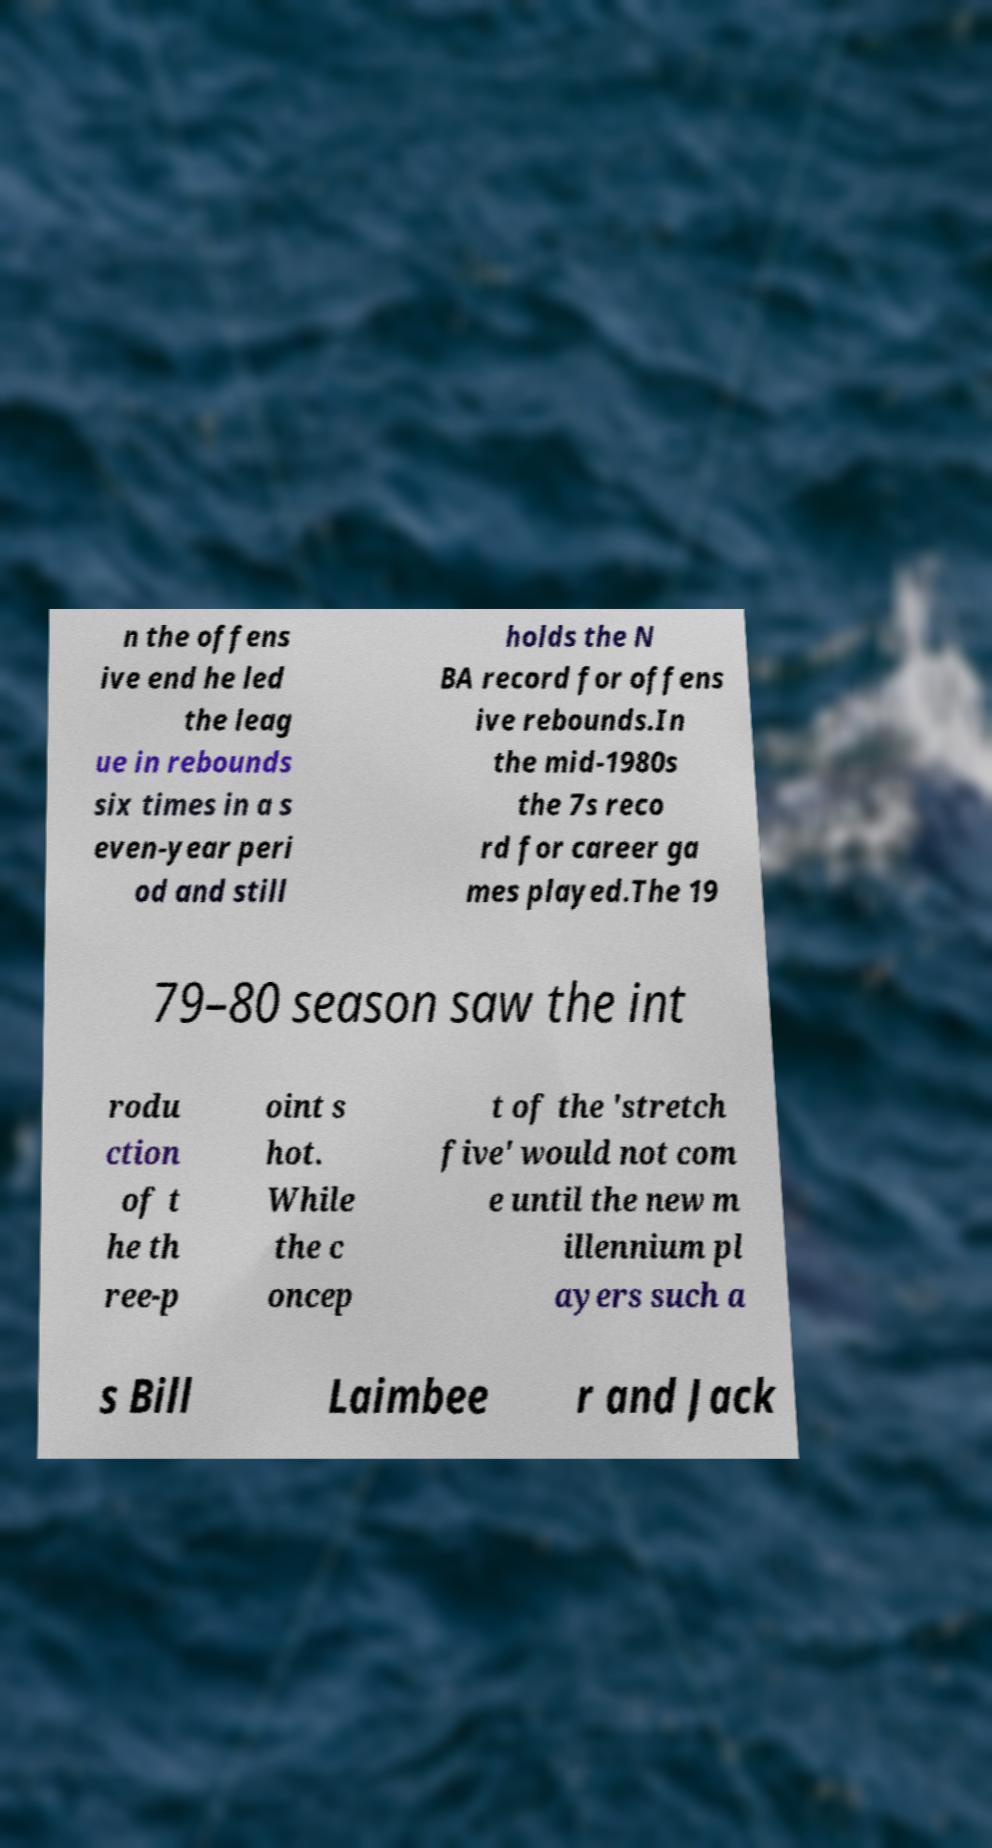There's text embedded in this image that I need extracted. Can you transcribe it verbatim? n the offens ive end he led the leag ue in rebounds six times in a s even-year peri od and still holds the N BA record for offens ive rebounds.In the mid-1980s the 7s reco rd for career ga mes played.The 19 79–80 season saw the int rodu ction of t he th ree-p oint s hot. While the c oncep t of the 'stretch five' would not com e until the new m illennium pl ayers such a s Bill Laimbee r and Jack 